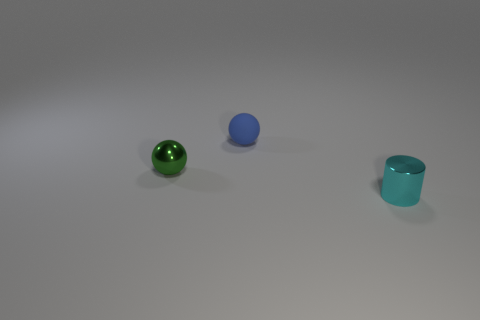Add 2 tiny metal spheres. How many objects exist? 5 Subtract all balls. How many objects are left? 1 Add 2 tiny cyan rubber cylinders. How many tiny cyan rubber cylinders exist? 2 Subtract 0 blue cylinders. How many objects are left? 3 Subtract all shiny cylinders. Subtract all green metal balls. How many objects are left? 1 Add 1 small metal cylinders. How many small metal cylinders are left? 2 